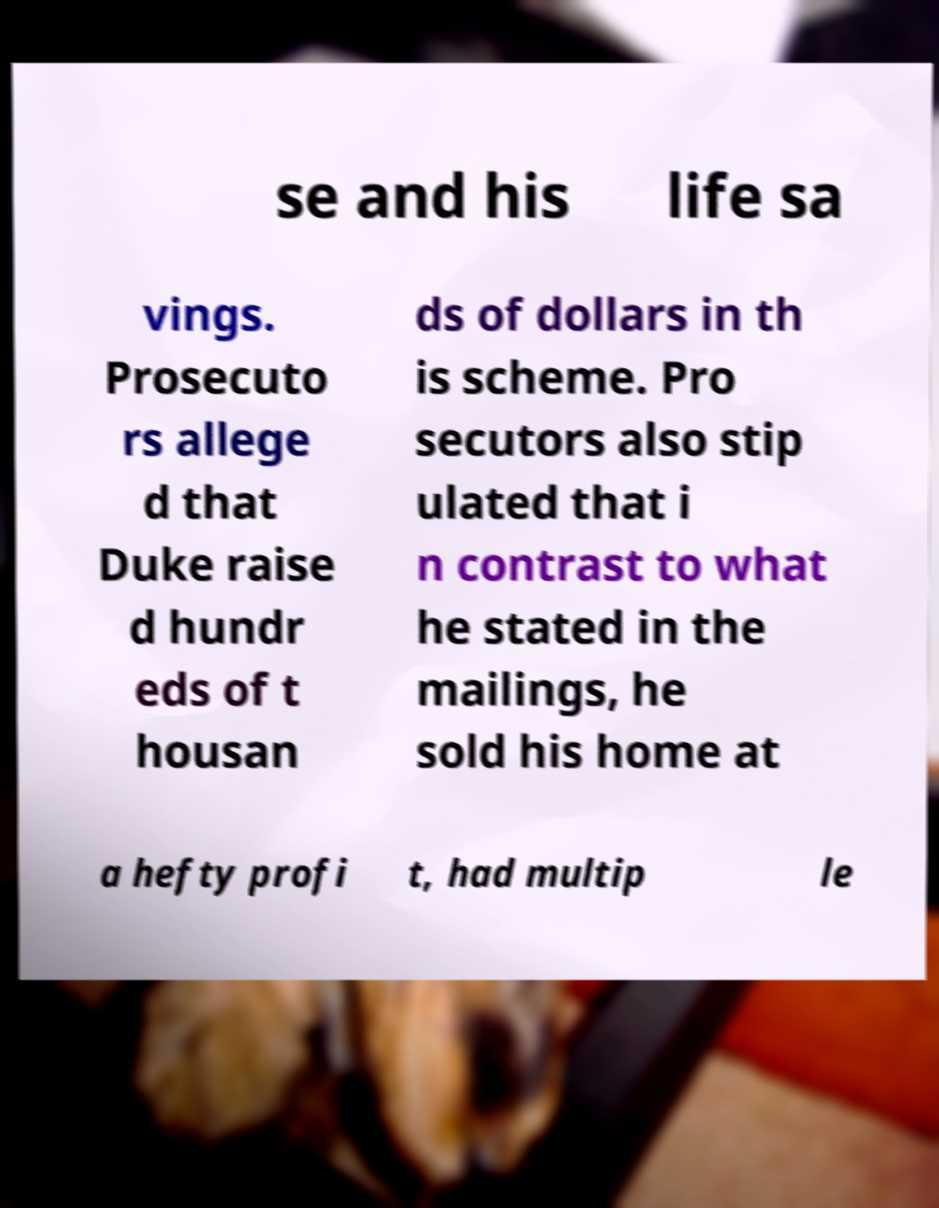Can you read and provide the text displayed in the image?This photo seems to have some interesting text. Can you extract and type it out for me? se and his life sa vings. Prosecuto rs allege d that Duke raise d hundr eds of t housan ds of dollars in th is scheme. Pro secutors also stip ulated that i n contrast to what he stated in the mailings, he sold his home at a hefty profi t, had multip le 